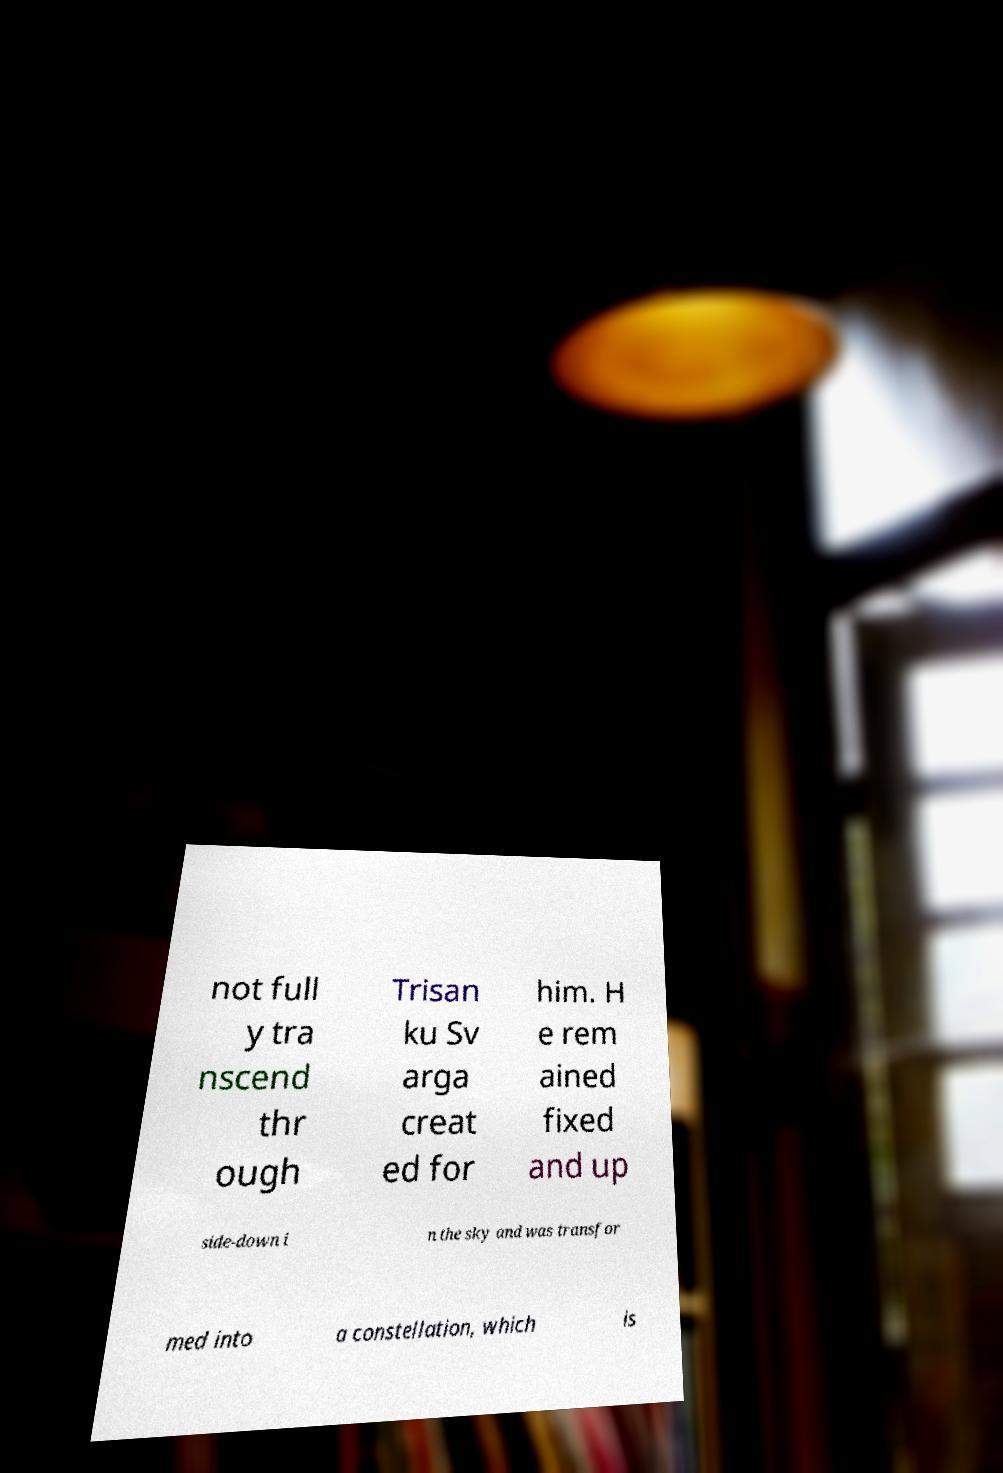Please read and relay the text visible in this image. What does it say? not full y tra nscend thr ough Trisan ku Sv arga creat ed for him. H e rem ained fixed and up side-down i n the sky and was transfor med into a constellation, which is 